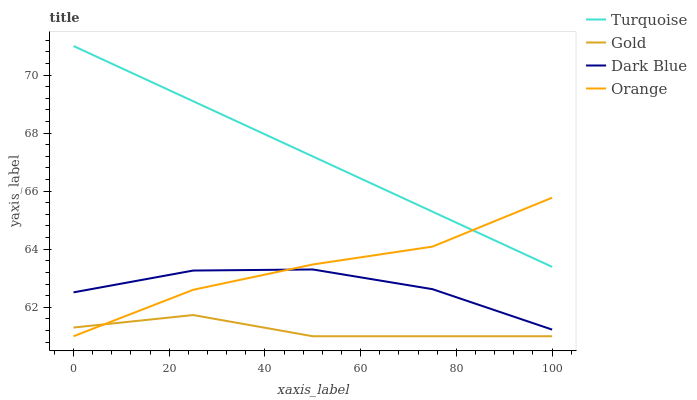Does Dark Blue have the minimum area under the curve?
Answer yes or no. No. Does Dark Blue have the maximum area under the curve?
Answer yes or no. No. Is Dark Blue the smoothest?
Answer yes or no. No. Is Turquoise the roughest?
Answer yes or no. No. Does Dark Blue have the lowest value?
Answer yes or no. No. Does Dark Blue have the highest value?
Answer yes or no. No. Is Gold less than Turquoise?
Answer yes or no. Yes. Is Turquoise greater than Dark Blue?
Answer yes or no. Yes. Does Gold intersect Turquoise?
Answer yes or no. No. 